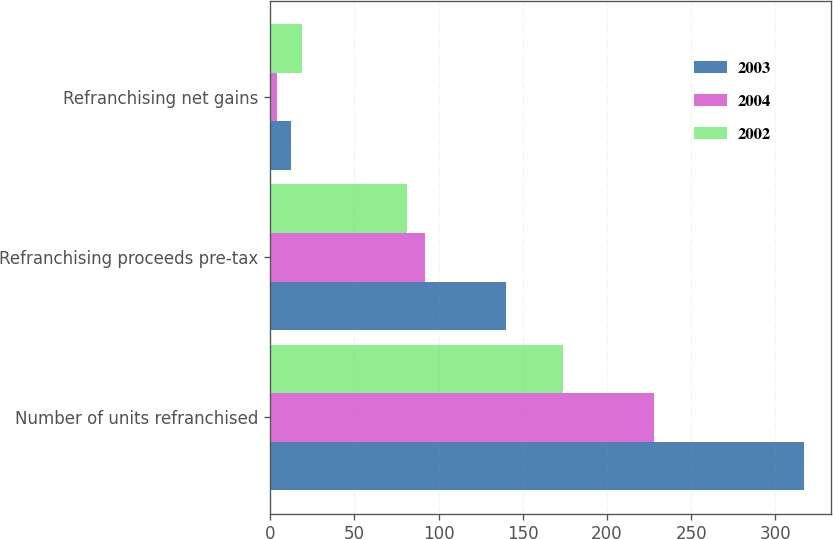Convert chart to OTSL. <chart><loc_0><loc_0><loc_500><loc_500><stacked_bar_chart><ecel><fcel>Number of units refranchised<fcel>Refranchising proceeds pre-tax<fcel>Refranchising net gains<nl><fcel>2003<fcel>317<fcel>140<fcel>12<nl><fcel>2004<fcel>228<fcel>92<fcel>4<nl><fcel>2002<fcel>174<fcel>81<fcel>19<nl></chart> 